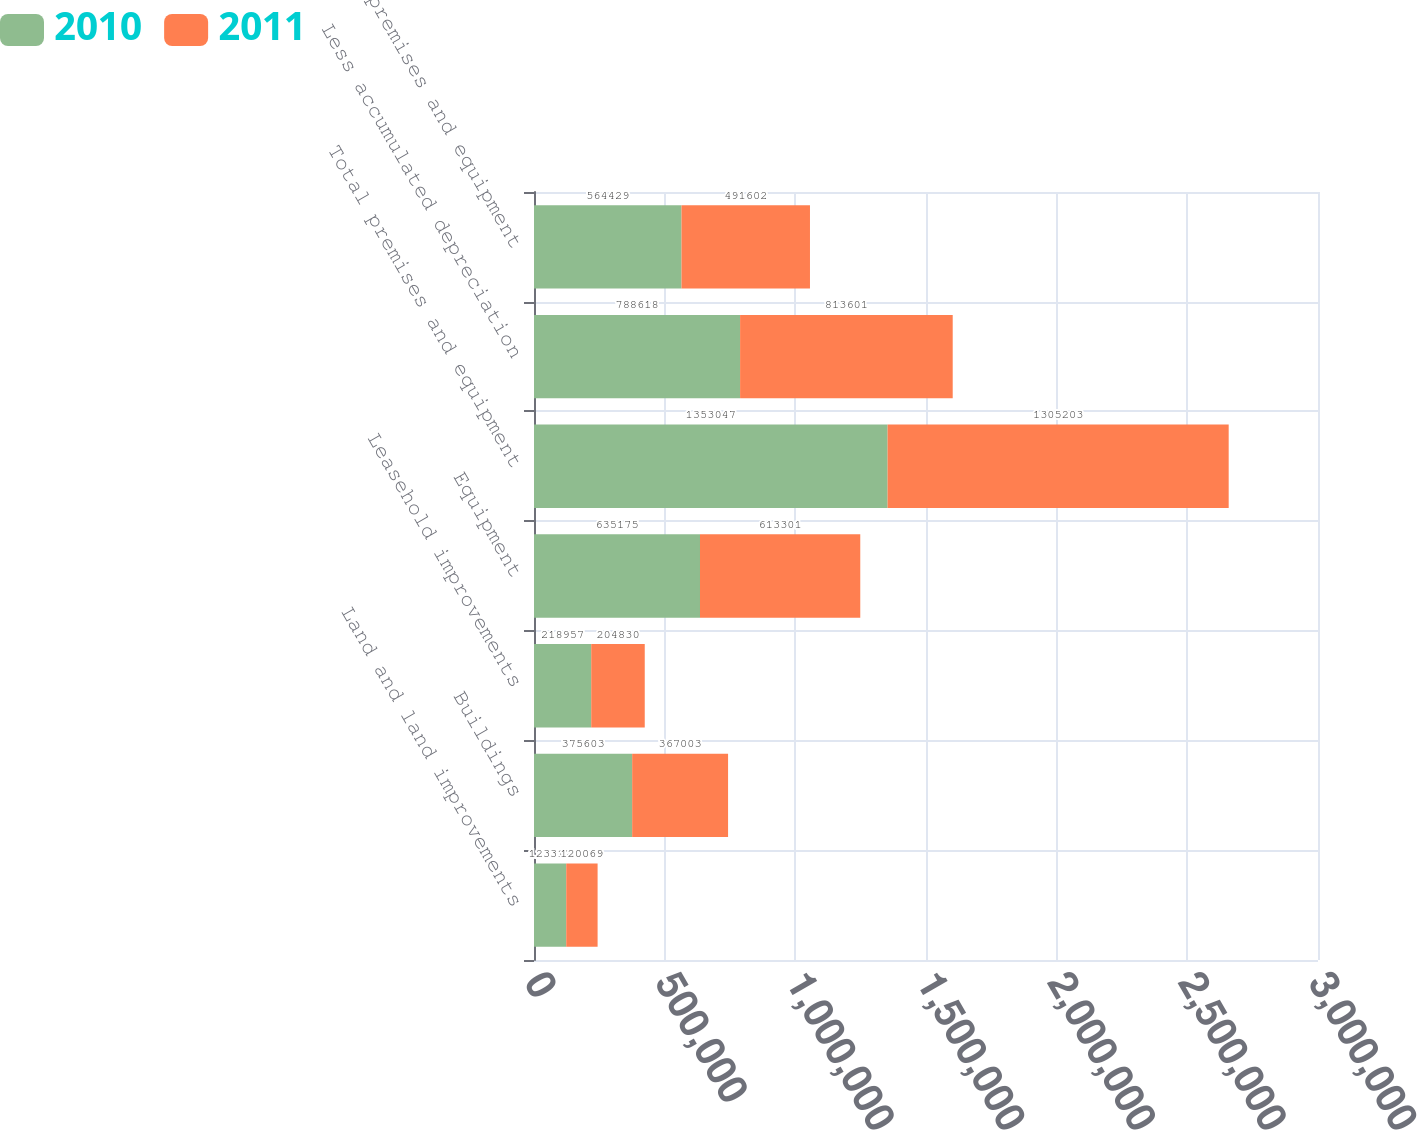Convert chart to OTSL. <chart><loc_0><loc_0><loc_500><loc_500><stacked_bar_chart><ecel><fcel>Land and land improvements<fcel>Buildings<fcel>Leasehold improvements<fcel>Equipment<fcel>Total premises and equipment<fcel>Less accumulated depreciation<fcel>Net premises and equipment<nl><fcel>2010<fcel>123312<fcel>375603<fcel>218957<fcel>635175<fcel>1.35305e+06<fcel>788618<fcel>564429<nl><fcel>2011<fcel>120069<fcel>367003<fcel>204830<fcel>613301<fcel>1.3052e+06<fcel>813601<fcel>491602<nl></chart> 